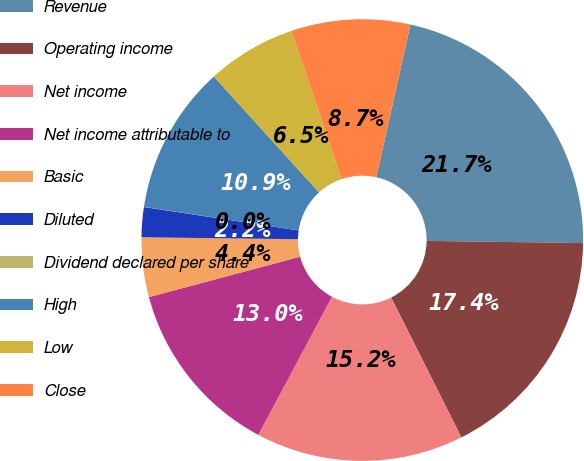Convert chart to OTSL. <chart><loc_0><loc_0><loc_500><loc_500><pie_chart><fcel>Revenue<fcel>Operating income<fcel>Net income<fcel>Net income attributable to<fcel>Basic<fcel>Diluted<fcel>Dividend declared per share<fcel>High<fcel>Low<fcel>Close<nl><fcel>21.72%<fcel>17.38%<fcel>15.21%<fcel>13.04%<fcel>4.36%<fcel>2.19%<fcel>0.01%<fcel>10.87%<fcel>6.53%<fcel>8.7%<nl></chart> 